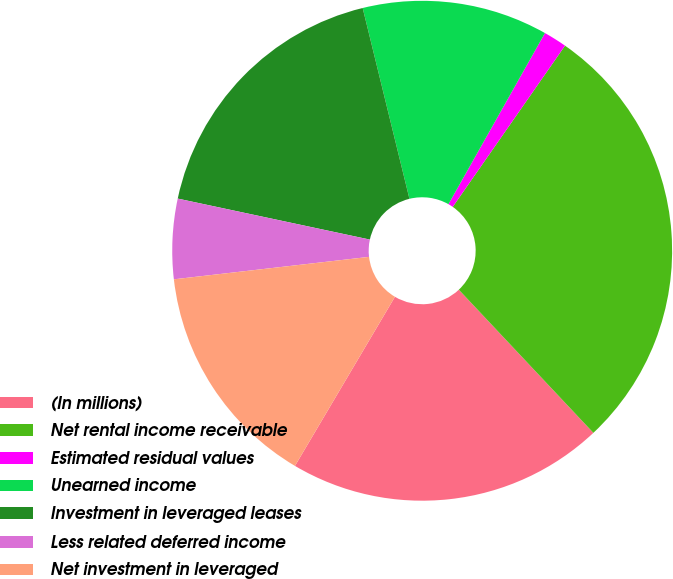<chart> <loc_0><loc_0><loc_500><loc_500><pie_chart><fcel>(In millions)<fcel>Net rental income receivable<fcel>Estimated residual values<fcel>Unearned income<fcel>Investment in leveraged leases<fcel>Less related deferred income<fcel>Net investment in leveraged<nl><fcel>20.51%<fcel>28.31%<fcel>1.51%<fcel>12.0%<fcel>17.83%<fcel>5.17%<fcel>14.68%<nl></chart> 